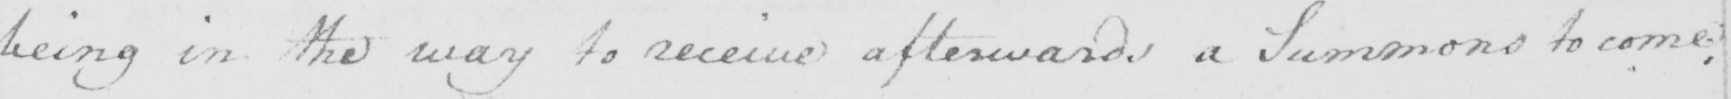Transcribe the text shown in this historical manuscript line. being in the way to receive afterwards a Summons to come ; 